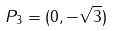Convert formula to latex. <formula><loc_0><loc_0><loc_500><loc_500>P _ { 3 } = ( 0 , - \sqrt { 3 } )</formula> 